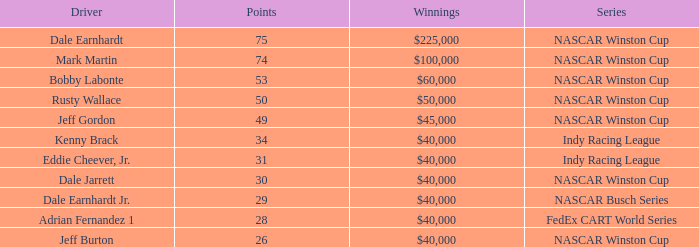How much did Jeff Burton win? $40,000. 